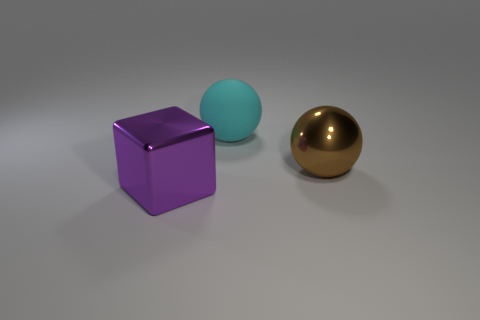Add 1 large purple matte blocks. How many objects exist? 4 Subtract all balls. How many objects are left? 1 Add 1 cyan matte objects. How many cyan matte objects are left? 2 Add 1 blue rubber blocks. How many blue rubber blocks exist? 1 Subtract 0 yellow cylinders. How many objects are left? 3 Subtract all big rubber cylinders. Subtract all rubber things. How many objects are left? 2 